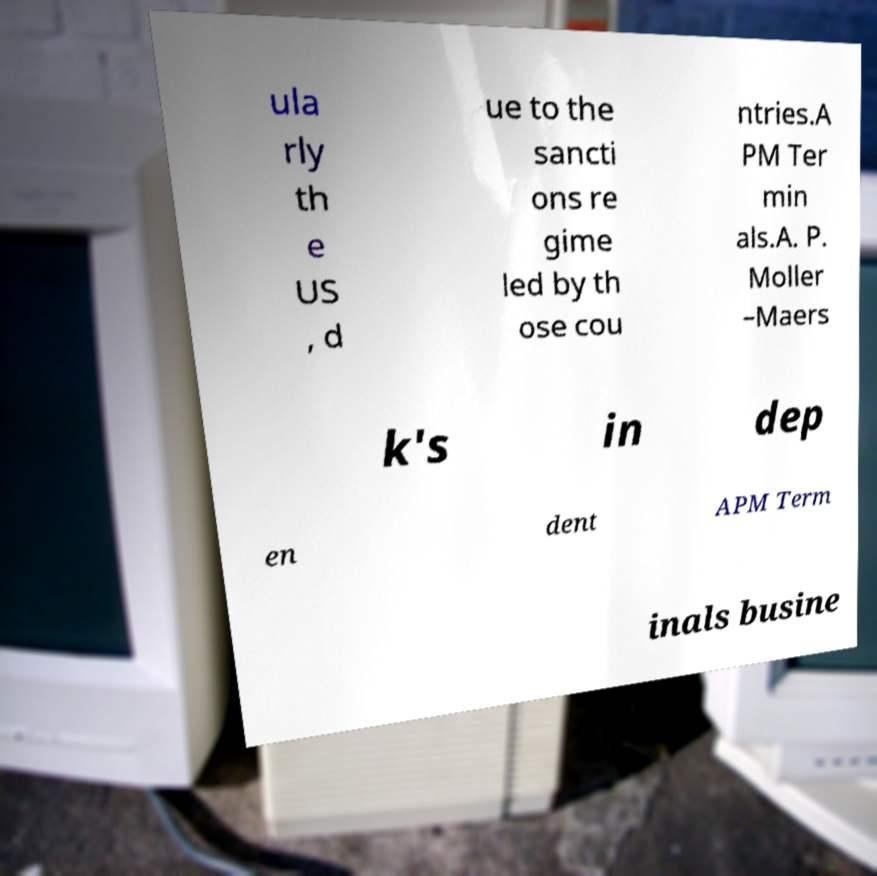For documentation purposes, I need the text within this image transcribed. Could you provide that? ula rly th e US , d ue to the sancti ons re gime led by th ose cou ntries.A PM Ter min als.A. P. Moller –Maers k's in dep en dent APM Term inals busine 